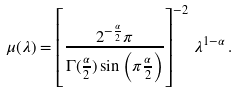Convert formula to latex. <formula><loc_0><loc_0><loc_500><loc_500>\mu ( \lambda ) = \left [ \frac { 2 ^ { - \frac { \alpha } { 2 } } \pi } { \Gamma ( \frac { \alpha } { 2 } ) \sin \left ( \pi \frac { \alpha } { 2 } \right ) } \right ] ^ { - 2 } \, \lambda ^ { 1 - \alpha } \, .</formula> 